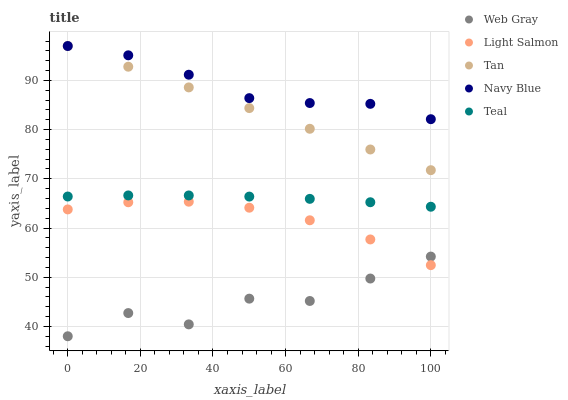Does Web Gray have the minimum area under the curve?
Answer yes or no. Yes. Does Navy Blue have the maximum area under the curve?
Answer yes or no. Yes. Does Light Salmon have the minimum area under the curve?
Answer yes or no. No. Does Light Salmon have the maximum area under the curve?
Answer yes or no. No. Is Tan the smoothest?
Answer yes or no. Yes. Is Web Gray the roughest?
Answer yes or no. Yes. Is Light Salmon the smoothest?
Answer yes or no. No. Is Light Salmon the roughest?
Answer yes or no. No. Does Web Gray have the lowest value?
Answer yes or no. Yes. Does Light Salmon have the lowest value?
Answer yes or no. No. Does Tan have the highest value?
Answer yes or no. Yes. Does Light Salmon have the highest value?
Answer yes or no. No. Is Teal less than Navy Blue?
Answer yes or no. Yes. Is Tan greater than Web Gray?
Answer yes or no. Yes. Does Tan intersect Navy Blue?
Answer yes or no. Yes. Is Tan less than Navy Blue?
Answer yes or no. No. Is Tan greater than Navy Blue?
Answer yes or no. No. Does Teal intersect Navy Blue?
Answer yes or no. No. 